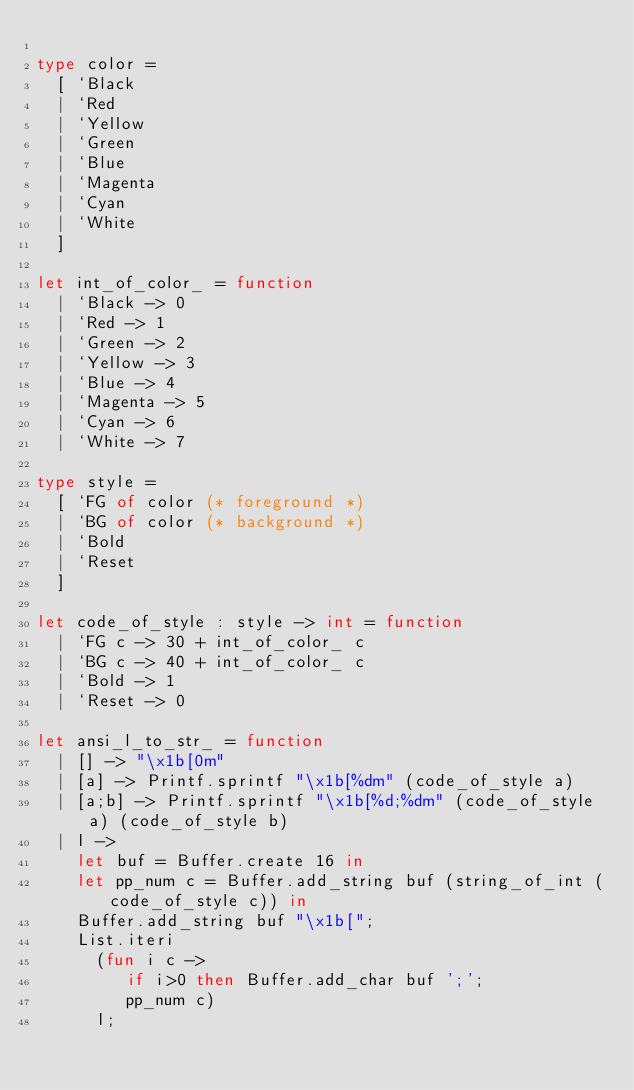Convert code to text. <code><loc_0><loc_0><loc_500><loc_500><_OCaml_>
type color =
  [ `Black
  | `Red
  | `Yellow
  | `Green
  | `Blue
  | `Magenta
  | `Cyan
  | `White
  ]

let int_of_color_ = function
  | `Black -> 0
  | `Red -> 1
  | `Green -> 2
  | `Yellow -> 3
  | `Blue -> 4
  | `Magenta -> 5
  | `Cyan -> 6
  | `White -> 7

type style =
  [ `FG of color (* foreground *)
  | `BG of color (* background *)
  | `Bold
  | `Reset
  ]

let code_of_style : style -> int = function
  | `FG c -> 30 + int_of_color_ c
  | `BG c -> 40 + int_of_color_ c
  | `Bold -> 1
  | `Reset -> 0

let ansi_l_to_str_ = function
  | [] -> "\x1b[0m"
  | [a] -> Printf.sprintf "\x1b[%dm" (code_of_style a)
  | [a;b] -> Printf.sprintf "\x1b[%d;%dm" (code_of_style a) (code_of_style b)
  | l ->
    let buf = Buffer.create 16 in
    let pp_num c = Buffer.add_string buf (string_of_int (code_of_style c)) in
    Buffer.add_string buf "\x1b[";
    List.iteri
      (fun i c ->
         if i>0 then Buffer.add_char buf ';';
         pp_num c)
      l;</code> 